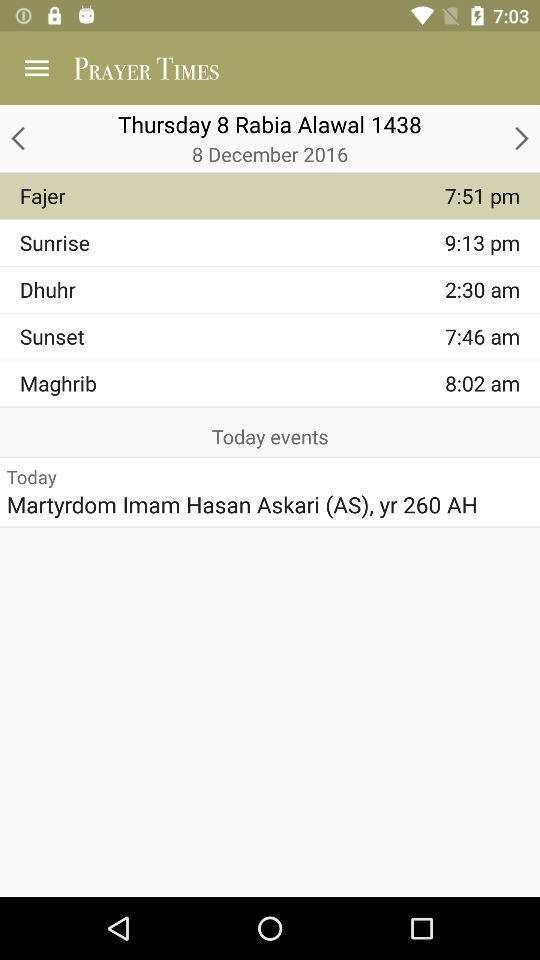What is the day today?
Answer the question using a single word or phrase. Today is Thursday. 